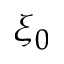Convert formula to latex. <formula><loc_0><loc_0><loc_500><loc_500>\xi _ { 0 }</formula> 